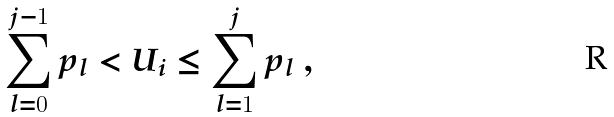Convert formula to latex. <formula><loc_0><loc_0><loc_500><loc_500>\sum _ { l = 0 } ^ { j - 1 } p _ { l } < U _ { i } \leq \sum _ { l = 1 } ^ { j } p _ { l } \ ,</formula> 